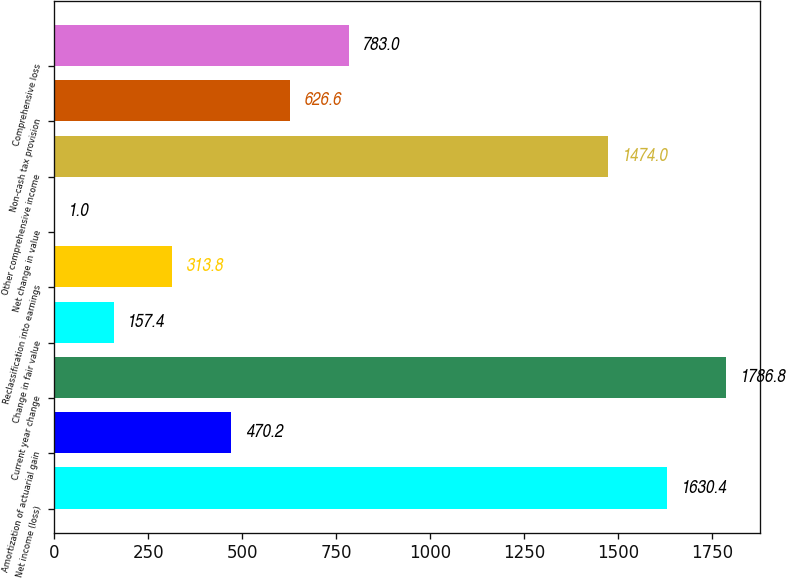<chart> <loc_0><loc_0><loc_500><loc_500><bar_chart><fcel>Net income (loss)<fcel>Amortization of actuarial gain<fcel>Current year change<fcel>Change in fair value<fcel>Reclassification into earnings<fcel>Net change in value<fcel>Other comprehensive income<fcel>Non-cash tax provision<fcel>Comprehensive loss<nl><fcel>1630.4<fcel>470.2<fcel>1786.8<fcel>157.4<fcel>313.8<fcel>1<fcel>1474<fcel>626.6<fcel>783<nl></chart> 